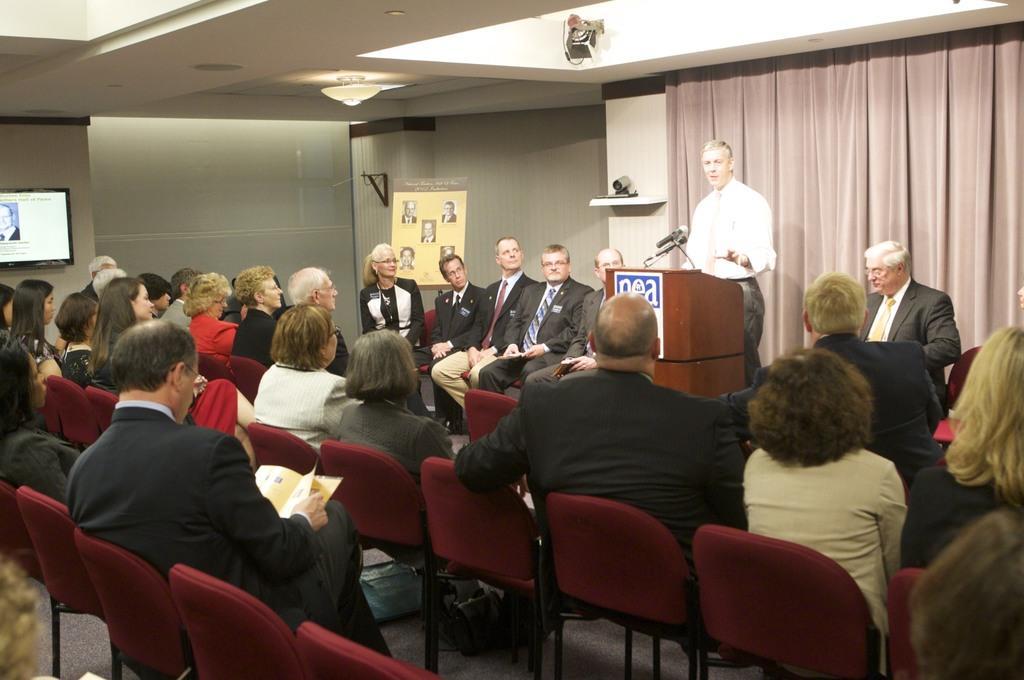Please provide a concise description of this image. Most of the persons are sitting on a chair. This person is standing, in-front of this person there is a podium with mic. On wall there is a camera. Television on wall. Far there is a banner. This person is holding a paper. 